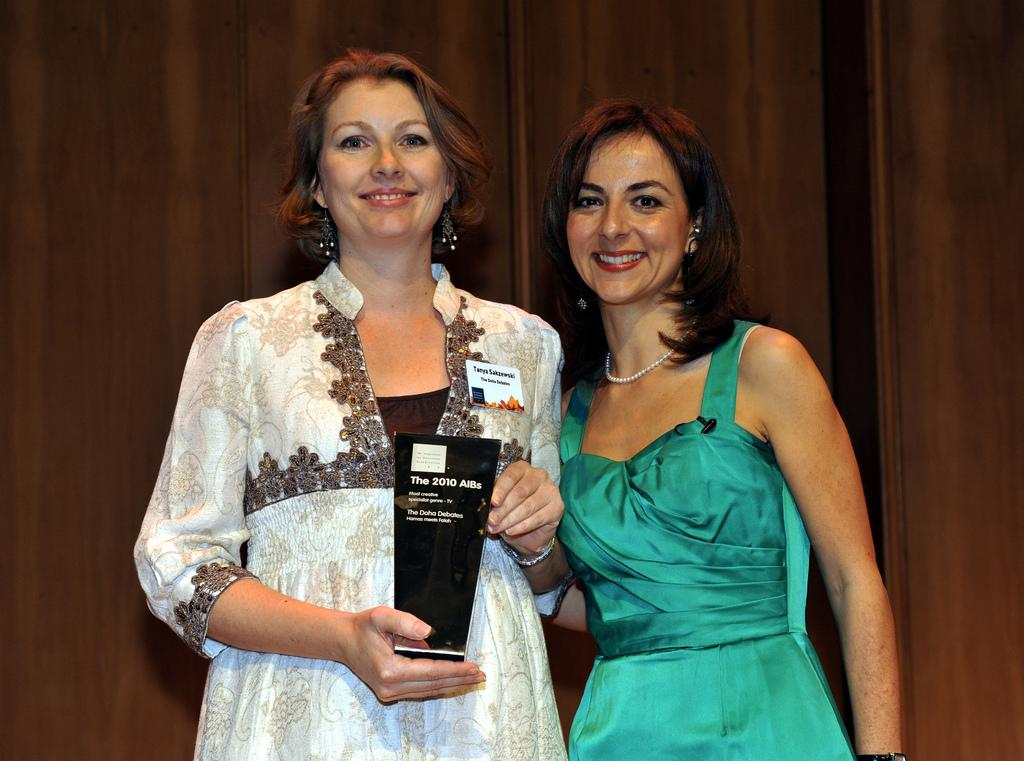How many women are present in the image? There are two women standing in the image. What is one of the women doing in the image? There is a woman holding an object in the image. What can be seen in the background of the image? There is a wooden wall in the background of the image. What type of animal is sitting on the head of one of the women in the image? There is no animal present on the head of either woman in the image. 